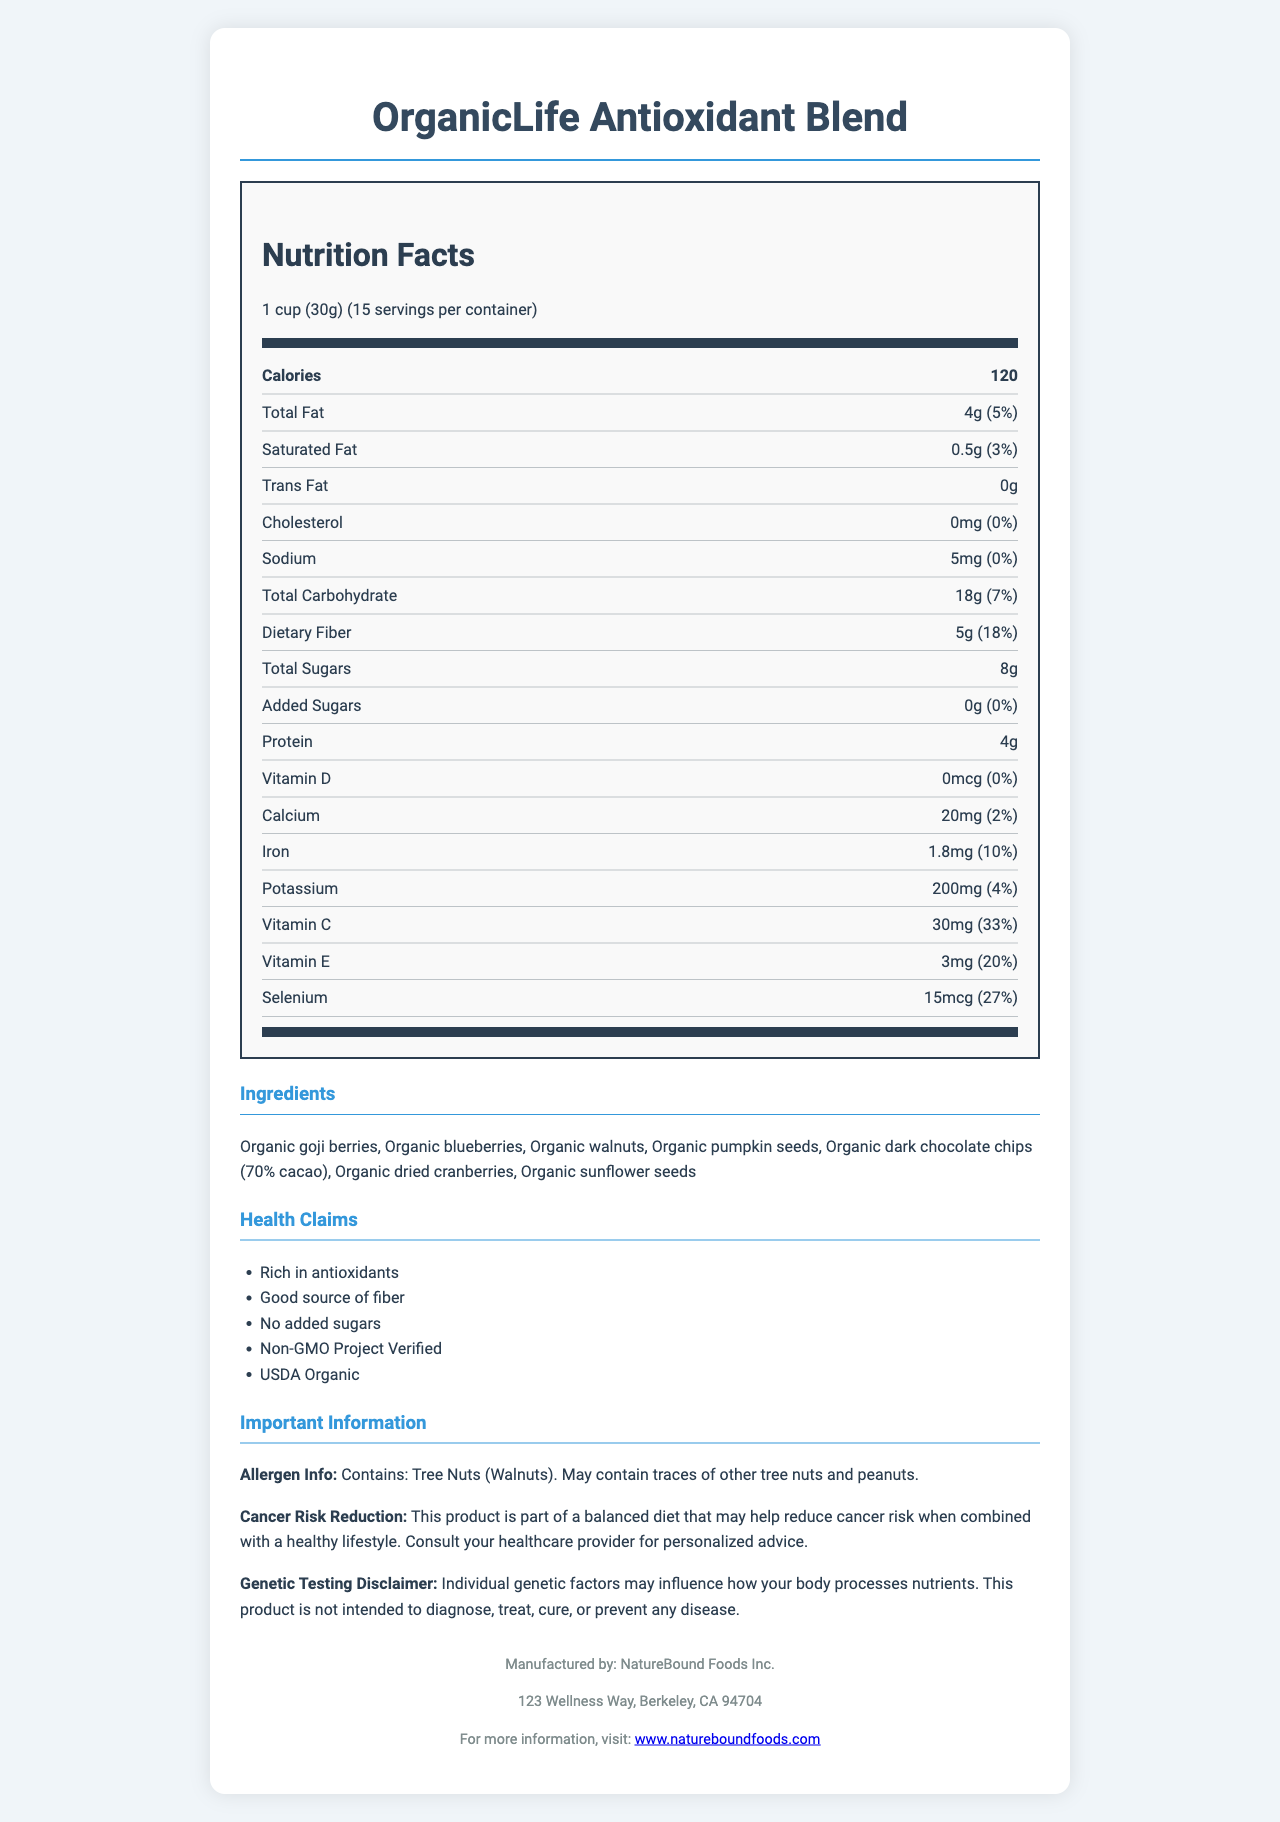what is the serving size for OrganicLife Antioxidant Blend? The serving size is listed at the top of the nutrition label as "1 cup (30g)".
Answer: 1 cup (30g) how many calories are in one serving of this product? The calories per serving are stated in the bold section as 120.
Answer: 120 calories how much dietary fiber is in each serving and what percent of the daily value does it represent? The dietary fiber information indicates 5g per serving which is 18% of the daily value.
Answer: 5g, 18% what are the main ingredients in the OrganicLife Antioxidant Blend? The ingredients are listed in the "Ingredients" section of the document.
Answer: Organic goji berries, Organic blueberries, Organic walnuts, Organic pumpkin seeds, Organic dark chocolate chips (70% cacao), Organic dried cranberries, Organic sunflower seeds how much total fat is in one serving? The total fat content per serving is shown as 4g in the nutrition label.
Answer: 4g which vitamin has the highest percent daily value in this product? A. Vitamin D B. Vitamin C C. Vitamin E Vitamin C has the highest percent daily value at 33%, followed by Vitamin E at 20%. Vitamin D is 0%.
Answer: B which of these health claims is not mentioned in the document? A. Rich in antioxidants B. High in protein C. Good source of fiber The document mentions "Rich in antioxidants", "Good source of fiber", "No added sugars", "Non-GMO Project Verified", and "USDA Organic" but does not mention "High in protein".
Answer: B does the OrganicLife Antioxidant Blend contain any added sugars? The nutrition label indicates 0g of added sugars.
Answer: No does this product contain any allergens? The allergen information specifies that it contains tree nuts (walnuts) and may contain traces of other tree nuts and peanuts.
Answer: Yes summarize the key information presented in this document. The document provides detailed nutritional information, ingredients, health claims, and manufacturer details about the OrganicLife Antioxidant Blend, highlighting its role in a cancer-risk reduction diet.
Answer: The OrganicLife Antioxidant Blend is an organic, non-GMO food product designed as part of a cancer-risk reduction diet. It has a serving size of 1 cup (30g) with 120 calories per serving and contains antioxidants and fiber. The product includes various organic ingredients like goji berries, blueberries, and dark chocolate chips. It has no added sugars and declares the potential presence of allergens like tree nuts. The manufacturer is NatureBound Foods Inc., and there is a disclaimer noting that genetic factors may influence nutrient processing. what is the exact address of the manufacturer? The address is found in the footer of the document under the manufacturer's information.
Answer: 123 Wellness Way, Berkeley, CA 94704 how many servings per container are there? The number of servings per container is listed at the top of the nutrition label as 15 servings.
Answer: 15 can this product diagnose, treat, cure, or prevent any disease? The genetic testing disclaimer states that the product is not intended to diagnose, treat, cure, or prevent any disease.
Answer: No how much vitamin D does one serving contain? The nutrition label shows that there is 0mcg of Vitamin D per serving.
Answer: 0mcg is the product Non-GMO Project Verified? One of the health claims listed is "Non-GMO Project Verified".
Answer: Yes which manufacturer produces the OrganicLife Antioxidant Blend? The manufacturer's name is provided in the footer of the document.
Answer: NatureBound Foods Inc. does this product contain any iron? The nutrition label indicates that each serving contains 1.8mg of iron, representing 10% of the daily value.
Answer: Yes can I find out the price of the OrganicLife Antioxidant Blend from this document? The document does not provide any information about the price of the product.
Answer: No 